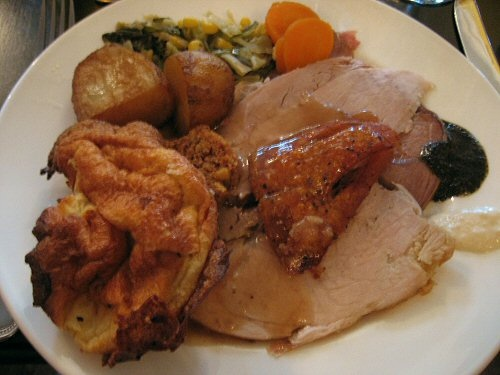Describe the objects in this image and their specific colors. I can see dining table in gray and black tones, carrot in gray, red, maroon, and tan tones, knife in gray, darkgray, and tan tones, broccoli in gray, black, olive, and tan tones, and fork in gray and black tones in this image. 